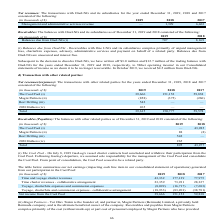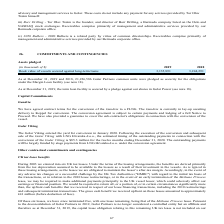From Golar Lng's financial document, In which years was the transaction with other related parties recorded for? The document contains multiple relevant values: 2019, 2018, 2017. From the document: "(in thousands of $) 2019 2018 2017 Management and administrative services revenue — 1,399 6,463 (in thousands of $) 2019 2018 2017 Management and admi..." Also, What are the different parties involved with the transactions? The document contains multiple relevant values: The Cool Pool, Magni Partners, Borr Drilling, 2020 Bulkers. From the document: "2018 2017 The Cool Pool (i) 39,666 151,152 59,838 Magni Partners (ii) (858) (375) (260) Borr Drilling (iii) 542 — — 2020 Bulkers (iv) 265 — — Total 39..." Also, Who is the founder of Borr Drilling? According to the financial document, Tor Olav Trøim. The relevant text states: "(ii) Magni Partners - Tor Olav Trøim is the founder of, and partner in, Magni Partners (Bermuda) Limited, a privately held Bermuda compa..." Additionally, In which year was the transaction with The Cool Pool the highest? According to the financial document, 2018. The relevant text states: "(in thousands of $) 2019 2018 2017 Management and administrative services revenue — 1,399 6,463..." Also, can you calculate: What was the change in total transaction with other related parties from 2018 to 2019? Based on the calculation: 39,615 - 150,777 , the result is -111162 (in thousands). This is based on the information: "ing (iii) 542 — — 2020 Bulkers (iv) 265 — — Total 39,615 150,777 59,578 i) 542 — — 2020 Bulkers (iv) 265 — — Total 39,615 150,777 59,578..." The key data points involved are: 150,777, 39,615. Also, can you calculate: What was the percentage change in total transaction with other related parties from 2017 to 2018? To answer this question, I need to perform calculations using the financial data. The calculation is: (150,777 - 59,578)/59,578 , which equals 153.07 (percentage). This is based on the information: "— 2020 Bulkers (iv) 265 — — Total 39,615 150,777 59,578 i) 542 — — 2020 Bulkers (iv) 265 — — Total 39,615 150,777 59,578..." The key data points involved are: 150,777, 59,578. 